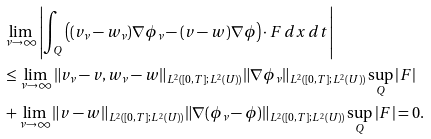<formula> <loc_0><loc_0><loc_500><loc_500>& \lim _ { \nu \rightarrow \infty } \left | \int _ { Q } \left ( ( v _ { \nu } - w _ { \nu } ) \nabla \phi _ { \nu } - ( v - w ) \nabla \phi \right ) \cdot F \, d x \, d t \right | \\ & \leq \lim _ { \nu \rightarrow \infty } \| v _ { \nu } - v , w _ { \nu } - w \| _ { L ^ { 2 } ( [ 0 , T ] ; L ^ { 2 } ( U ) ) } \| \nabla \phi _ { \nu } \| _ { L ^ { 2 } ( [ 0 , T ] ; L ^ { 2 } ( U ) ) } \sup _ { Q } | F | \\ & + \lim _ { \nu \rightarrow \infty } \| v - w \| _ { L ^ { 2 } ( [ 0 , T ] ; L ^ { 2 } ( U ) ) } \| \nabla ( \phi _ { \nu } - \phi ) \| _ { L ^ { 2 } ( [ 0 , T ] ; L ^ { 2 } ( U ) ) } \sup _ { Q } | F | = 0 .</formula> 